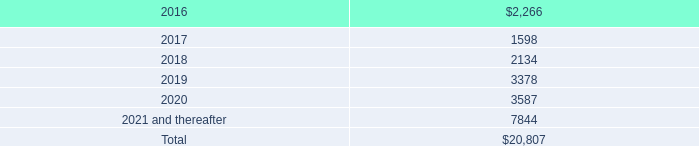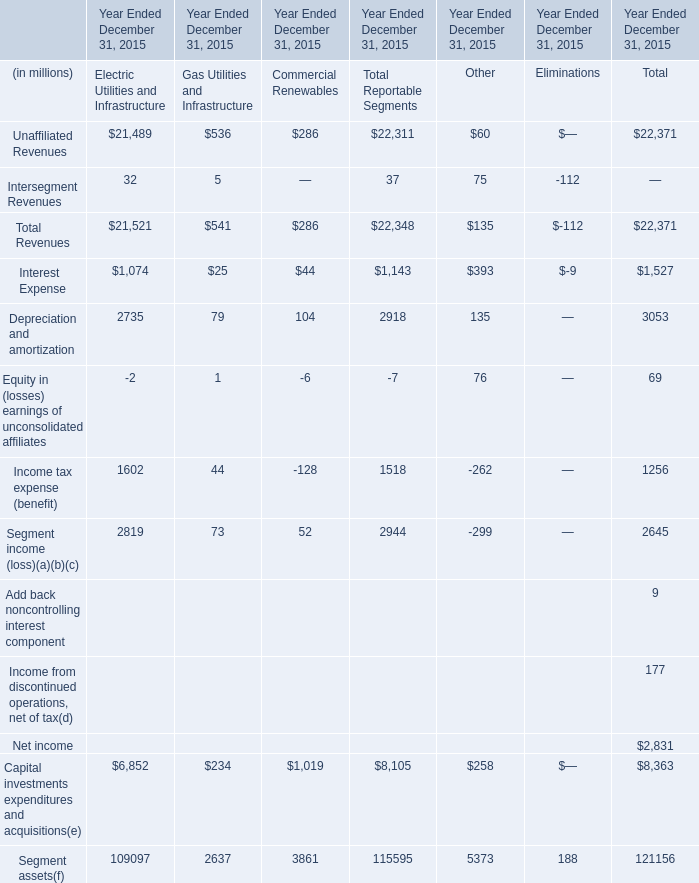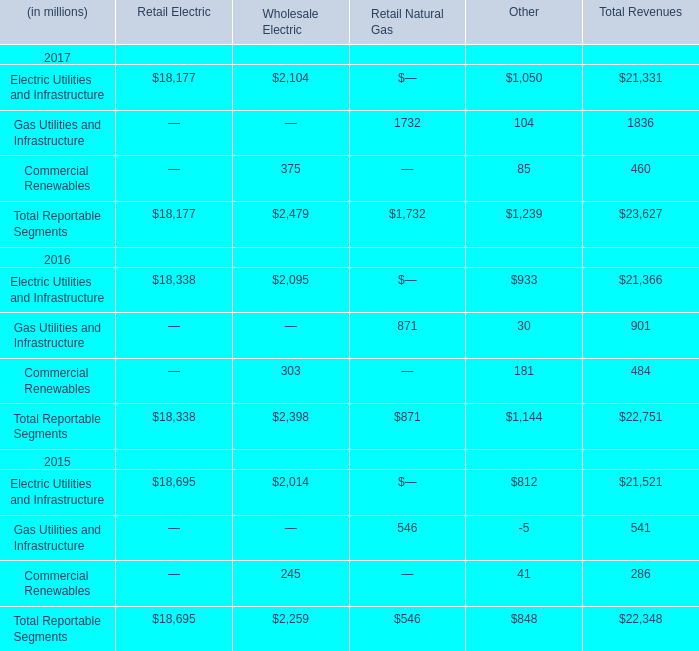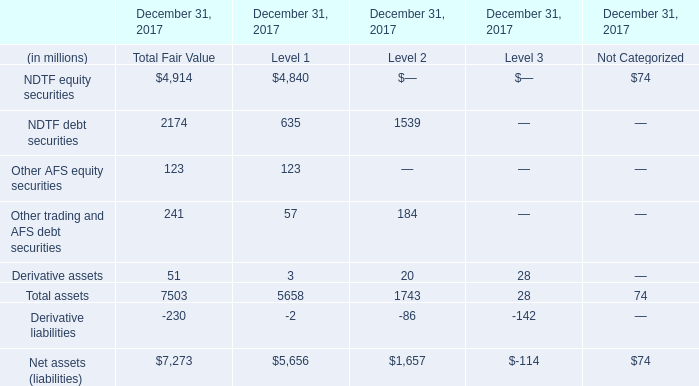In which years is Gas Utilities and Infrastructure in Other greater than Commercial Renewables in Other? 
Answer: 2017. 